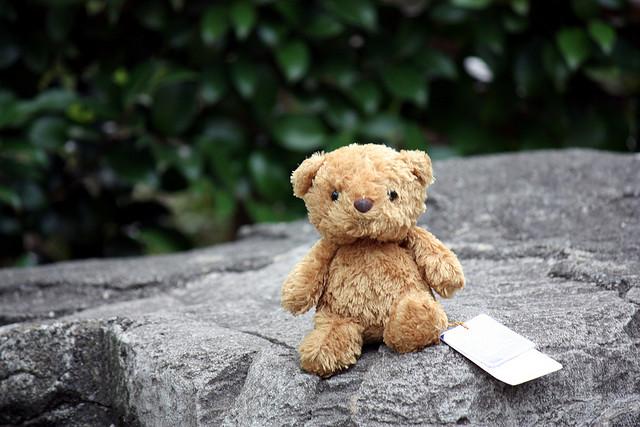Would this be an appropriate gift for a small child?
Keep it brief. Yes. Is this picture set in a toy store?
Give a very brief answer. No. Is this a stuffed animal?
Quick response, please. Yes. Why does the toy have a tag attached to it?
Answer briefly. Price. 